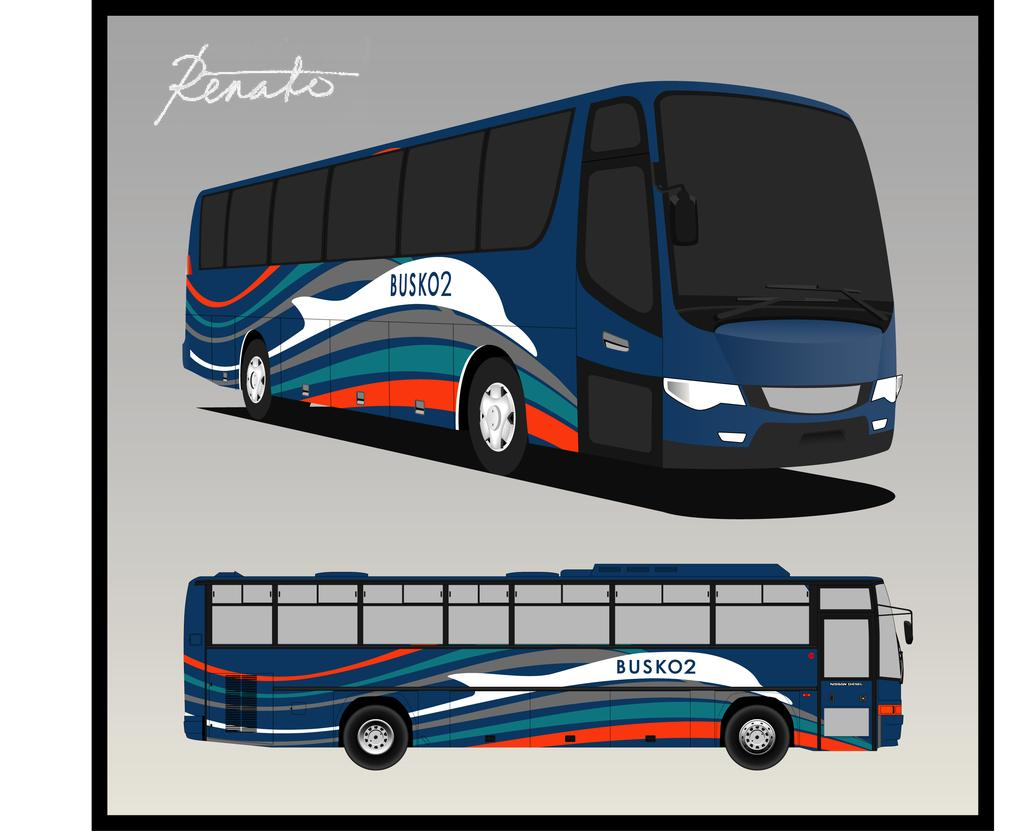How many buses are in the image? There are two buses in the image. What is the nature of the buses in the image? The buses are animated. How are the buses positioned in relation to each other? The buses are positioned one above the other. What can be seen on the left side of the image? There is some text on the left side of the image. What type of cheese is being used to hold the buses together in the image? There is no cheese present in the image, and the buses are not being held together. 